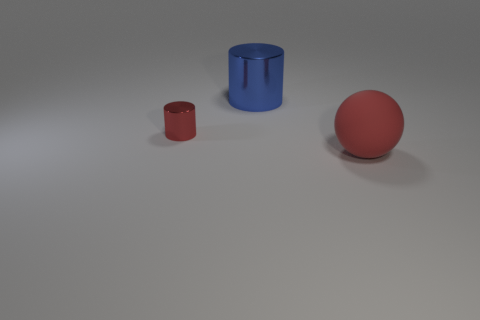Add 3 red matte things. How many objects exist? 6 Subtract all spheres. How many objects are left? 2 Subtract all large cyan matte things. Subtract all large blue cylinders. How many objects are left? 2 Add 3 big rubber spheres. How many big rubber spheres are left? 4 Add 3 red balls. How many red balls exist? 4 Subtract 0 yellow cubes. How many objects are left? 3 